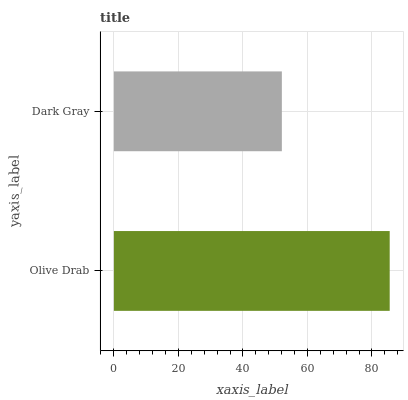Is Dark Gray the minimum?
Answer yes or no. Yes. Is Olive Drab the maximum?
Answer yes or no. Yes. Is Dark Gray the maximum?
Answer yes or no. No. Is Olive Drab greater than Dark Gray?
Answer yes or no. Yes. Is Dark Gray less than Olive Drab?
Answer yes or no. Yes. Is Dark Gray greater than Olive Drab?
Answer yes or no. No. Is Olive Drab less than Dark Gray?
Answer yes or no. No. Is Olive Drab the high median?
Answer yes or no. Yes. Is Dark Gray the low median?
Answer yes or no. Yes. Is Dark Gray the high median?
Answer yes or no. No. Is Olive Drab the low median?
Answer yes or no. No. 